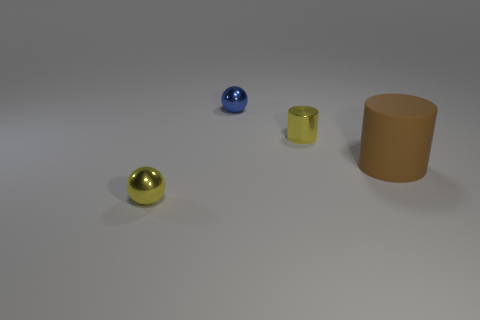Add 3 blue objects. How many objects exist? 7 Subtract 1 cylinders. How many cylinders are left? 1 Subtract all cyan blocks. How many brown cylinders are left? 1 Subtract all blue shiny balls. Subtract all brown matte cylinders. How many objects are left? 2 Add 4 tiny metallic balls. How many tiny metallic balls are left? 6 Add 2 yellow metallic cylinders. How many yellow metallic cylinders exist? 3 Subtract 0 green spheres. How many objects are left? 4 Subtract all gray balls. Subtract all yellow blocks. How many balls are left? 2 